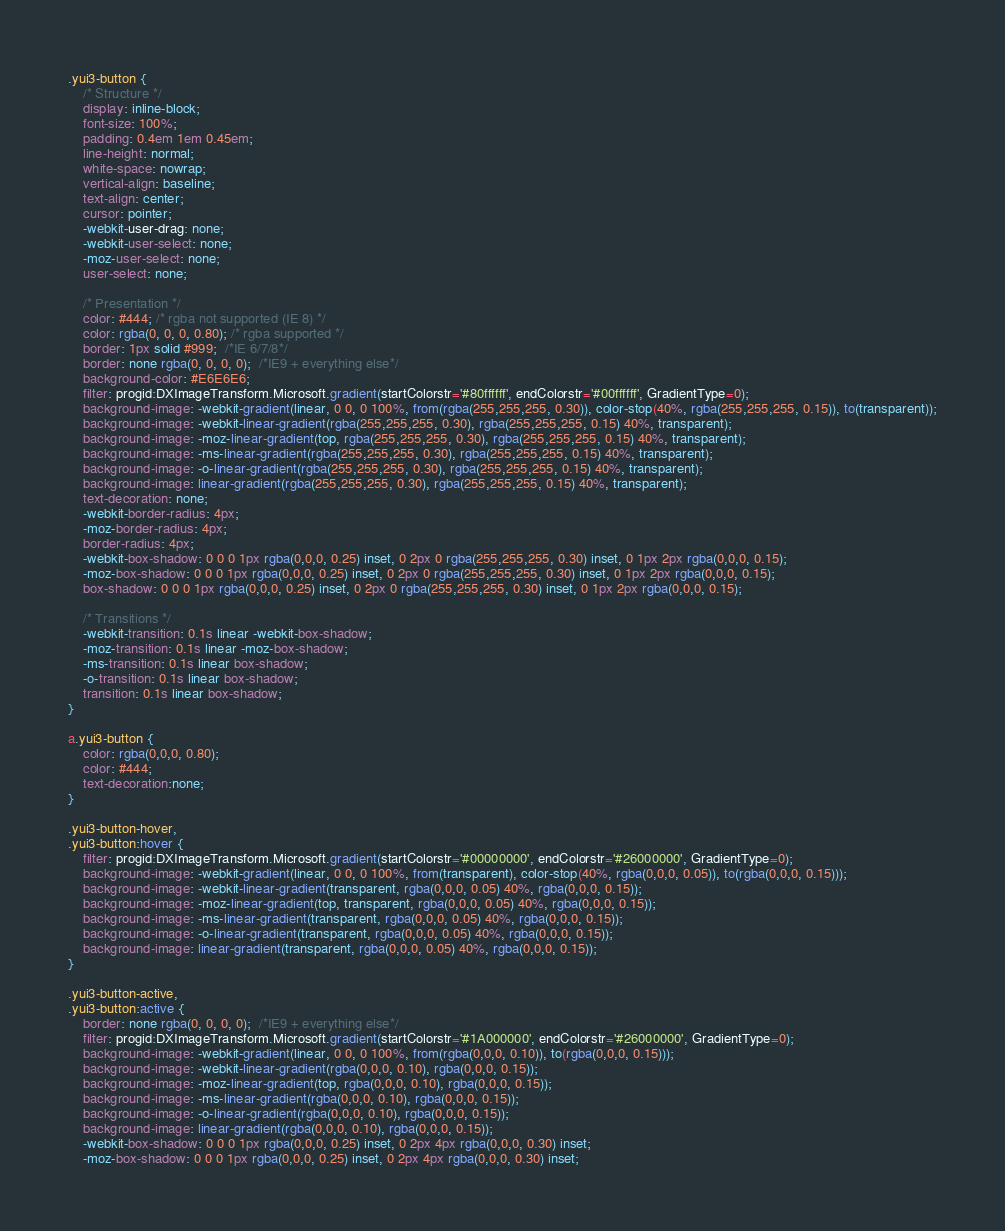Convert code to text. <code><loc_0><loc_0><loc_500><loc_500><_CSS_>.yui3-button {
    /* Structure */
    display: inline-block;
    font-size: 100%;
    padding: 0.4em 1em 0.45em;
    line-height: normal;
    white-space: nowrap;
    vertical-align: baseline;
    text-align: center;
    cursor: pointer;
    -webkit-user-drag: none;
    -webkit-user-select: none;
    -moz-user-select: none;
    user-select: none;

    /* Presentation */
    color: #444; /* rgba not supported (IE 8) */
    color: rgba(0, 0, 0, 0.80); /* rgba supported */
    border: 1px solid #999;  /*IE 6/7/8*/
    border: none rgba(0, 0, 0, 0);  /*IE9 + everything else*/
    background-color: #E6E6E6;
    filter: progid:DXImageTransform.Microsoft.gradient(startColorstr='#80ffffff', endColorstr='#00ffffff', GradientType=0);
    background-image: -webkit-gradient(linear, 0 0, 0 100%, from(rgba(255,255,255, 0.30)), color-stop(40%, rgba(255,255,255, 0.15)), to(transparent));
    background-image: -webkit-linear-gradient(rgba(255,255,255, 0.30), rgba(255,255,255, 0.15) 40%, transparent);
    background-image: -moz-linear-gradient(top, rgba(255,255,255, 0.30), rgba(255,255,255, 0.15) 40%, transparent);
    background-image: -ms-linear-gradient(rgba(255,255,255, 0.30), rgba(255,255,255, 0.15) 40%, transparent);
    background-image: -o-linear-gradient(rgba(255,255,255, 0.30), rgba(255,255,255, 0.15) 40%, transparent);
    background-image: linear-gradient(rgba(255,255,255, 0.30), rgba(255,255,255, 0.15) 40%, transparent);
    text-decoration: none;
    -webkit-border-radius: 4px;
    -moz-border-radius: 4px;
    border-radius: 4px;
    -webkit-box-shadow: 0 0 0 1px rgba(0,0,0, 0.25) inset, 0 2px 0 rgba(255,255,255, 0.30) inset, 0 1px 2px rgba(0,0,0, 0.15);
    -moz-box-shadow: 0 0 0 1px rgba(0,0,0, 0.25) inset, 0 2px 0 rgba(255,255,255, 0.30) inset, 0 1px 2px rgba(0,0,0, 0.15);
    box-shadow: 0 0 0 1px rgba(0,0,0, 0.25) inset, 0 2px 0 rgba(255,255,255, 0.30) inset, 0 1px 2px rgba(0,0,0, 0.15);

    /* Transitions */
    -webkit-transition: 0.1s linear -webkit-box-shadow;
    -moz-transition: 0.1s linear -moz-box-shadow;
    -ms-transition: 0.1s linear box-shadow;
    -o-transition: 0.1s linear box-shadow;
    transition: 0.1s linear box-shadow;
}

a.yui3-button {
    color: rgba(0,0,0, 0.80);
    color: #444;
    text-decoration:none;
}

.yui3-button-hover,
.yui3-button:hover {
    filter: progid:DXImageTransform.Microsoft.gradient(startColorstr='#00000000', endColorstr='#26000000', GradientType=0);
    background-image: -webkit-gradient(linear, 0 0, 0 100%, from(transparent), color-stop(40%, rgba(0,0,0, 0.05)), to(rgba(0,0,0, 0.15)));
    background-image: -webkit-linear-gradient(transparent, rgba(0,0,0, 0.05) 40%, rgba(0,0,0, 0.15));
    background-image: -moz-linear-gradient(top, transparent, rgba(0,0,0, 0.05) 40%, rgba(0,0,0, 0.15));
    background-image: -ms-linear-gradient(transparent, rgba(0,0,0, 0.05) 40%, rgba(0,0,0, 0.15));
    background-image: -o-linear-gradient(transparent, rgba(0,0,0, 0.05) 40%, rgba(0,0,0, 0.15));
    background-image: linear-gradient(transparent, rgba(0,0,0, 0.05) 40%, rgba(0,0,0, 0.15));
}

.yui3-button-active,
.yui3-button:active {
    border: none rgba(0, 0, 0, 0);  /*IE9 + everything else*/
    filter: progid:DXImageTransform.Microsoft.gradient(startColorstr='#1A000000', endColorstr='#26000000', GradientType=0);
    background-image: -webkit-gradient(linear, 0 0, 0 100%, from(rgba(0,0,0, 0.10)), to(rgba(0,0,0, 0.15)));
    background-image: -webkit-linear-gradient(rgba(0,0,0, 0.10), rgba(0,0,0, 0.15));
    background-image: -moz-linear-gradient(top, rgba(0,0,0, 0.10), rgba(0,0,0, 0.15));
    background-image: -ms-linear-gradient(rgba(0,0,0, 0.10), rgba(0,0,0, 0.15));
    background-image: -o-linear-gradient(rgba(0,0,0, 0.10), rgba(0,0,0, 0.15));
    background-image: linear-gradient(rgba(0,0,0, 0.10), rgba(0,0,0, 0.15));
    -webkit-box-shadow: 0 0 0 1px rgba(0,0,0, 0.25) inset, 0 2px 4px rgba(0,0,0, 0.30) inset;
    -moz-box-shadow: 0 0 0 1px rgba(0,0,0, 0.25) inset, 0 2px 4px rgba(0,0,0, 0.30) inset;</code> 